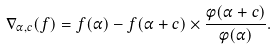<formula> <loc_0><loc_0><loc_500><loc_500>\nabla _ { \alpha , c } ( f ) = f ( \alpha ) - f ( \alpha + c ) \times \frac { \phi ( \alpha + c ) } { \phi ( \alpha ) } .</formula> 